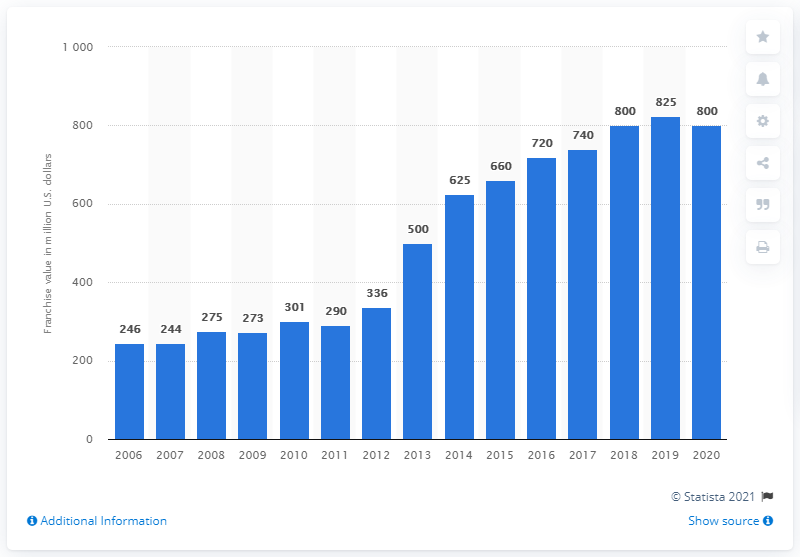List a handful of essential elements in this visual. The estimated value of the Philadelphia Flyers in dollars in 2020 was approximately 800. 